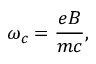Convert formula to latex. <formula><loc_0><loc_0><loc_500><loc_500>\omega _ { c } = { \frac { e B } { m c } } ,</formula> 